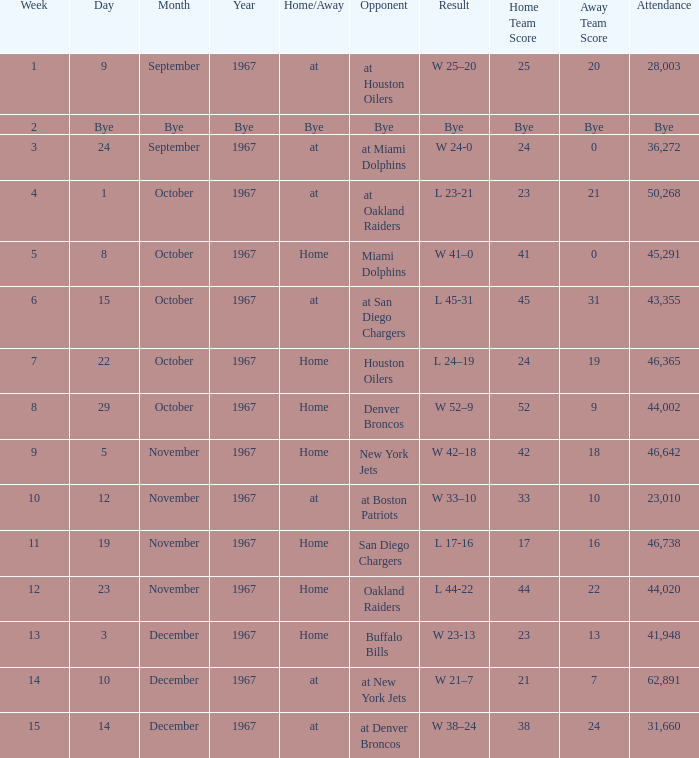What was the date of the game after week 5 against the Houston Oilers? October 22, 1967. Parse the table in full. {'header': ['Week', 'Day', 'Month', 'Year', 'Home/Away', 'Opponent', 'Result', 'Home Team Score', 'Away Team Score', 'Attendance'], 'rows': [['1', '9', 'September', '1967', 'at', 'at Houston Oilers', 'W 25–20', '25', '20', '28,003'], ['2', 'Bye', 'Bye', 'Bye', 'Bye', 'Bye', 'Bye', 'Bye', 'Bye', 'Bye'], ['3', '24', 'September', '1967', 'at', 'at Miami Dolphins', 'W 24-0', '24', '0', '36,272'], ['4', '1', 'October', '1967', 'at', 'at Oakland Raiders', 'L 23-21', '23', '21', '50,268'], ['5', '8', 'October', '1967', 'Home', 'Miami Dolphins', 'W 41–0', '41', '0', '45,291'], ['6', '15', 'October', '1967', 'at', 'at San Diego Chargers', 'L 45-31', '45', '31', '43,355'], ['7', '22', 'October', '1967', 'Home', 'Houston Oilers', 'L 24–19', '24', '19', '46,365'], ['8', '29', 'October', '1967', 'Home', 'Denver Broncos', 'W 52–9', '52', '9', '44,002'], ['9', '5', 'November', '1967', 'Home', 'New York Jets', 'W 42–18', '42', '18', '46,642'], ['10', '12', 'November', '1967', 'at', 'at Boston Patriots', 'W 33–10', '33', '10', '23,010'], ['11', '19', 'November', '1967', 'Home', 'San Diego Chargers', 'L 17-16', '17', '16', '46,738'], ['12', '23', 'November', '1967', 'Home', 'Oakland Raiders', 'L 44-22', '44', '22', '44,020'], ['13', '3', 'December', '1967', 'Home', 'Buffalo Bills', 'W 23-13', '23', '13', '41,948'], ['14', '10', 'December', '1967', 'at', 'at New York Jets', 'W 21–7', '21', '7', '62,891'], ['15', '14', 'December', '1967', 'at', 'at Denver Broncos', 'W 38–24', '38', '24', '31,660']]} 